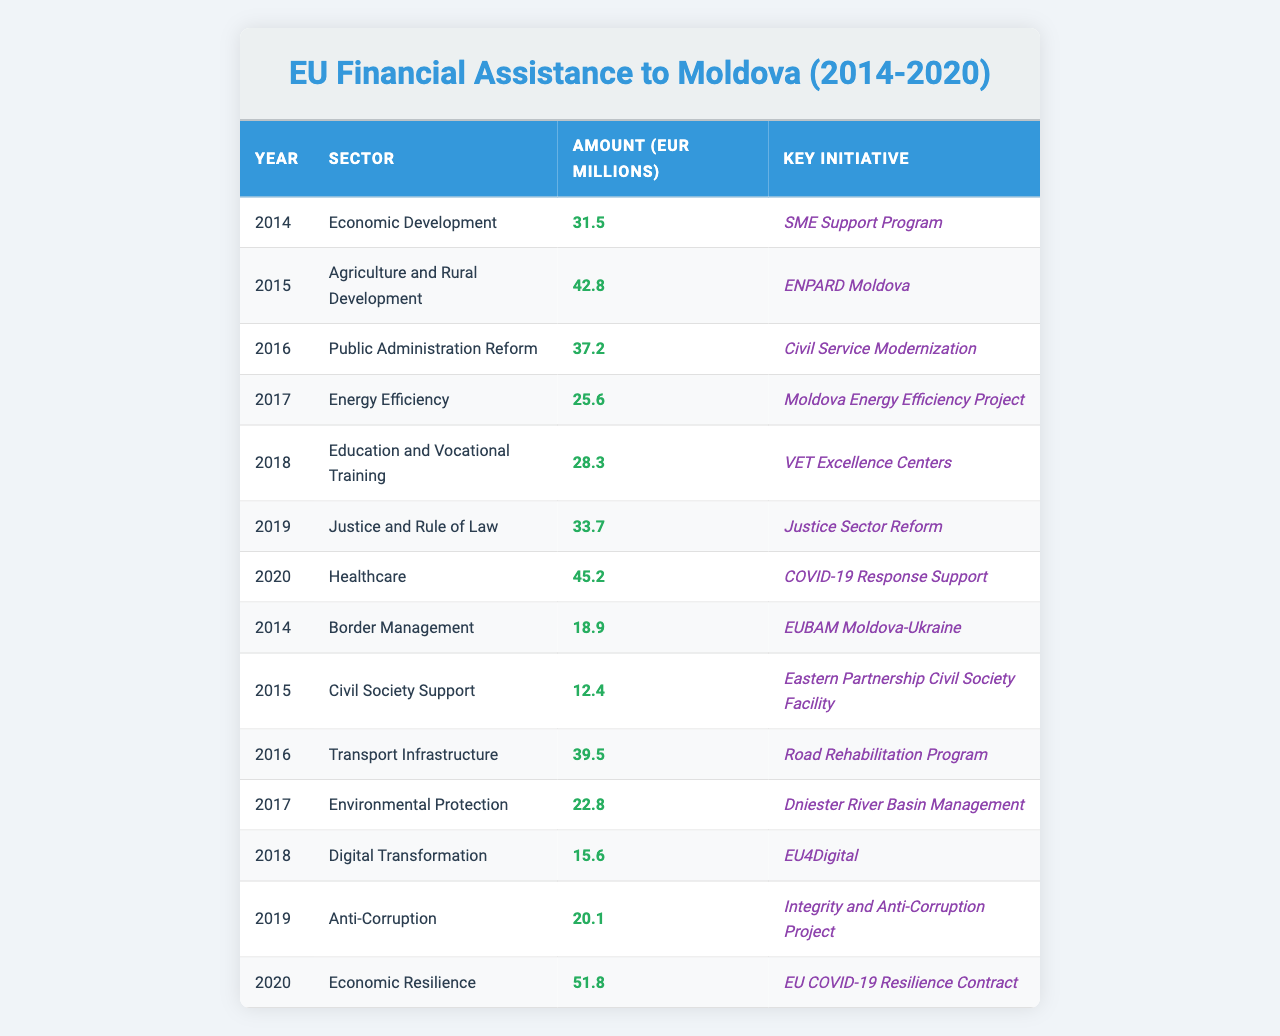What is the total amount of EU financial assistance given to Moldova in 2019? In 2019, the table shows two sectors with financial assistance: Justice and Rule of Law with 33.7 million EUR and Anti-Corruption with 20.1 million EUR. To find the total for 2019, we add these amounts: 33.7 + 20.1 = 53.8 million EUR.
Answer: 53.8 million EUR What was the highest amount of financial assistance in a single year between 2014 and 2020? Looking at the table, the highest single amount is in 2020 under Economic Resilience, which is 51.8 million EUR. All other years have lower amounts.
Answer: 51.8 million EUR In which sector was the least financial assistance provided in 2017? In 2017, the sectors listed are Energy Efficiency with 25.6 million EUR and Environmental Protection with 22.8 million EUR. The least assistance is in Environmental Protection.
Answer: Environmental Protection What is the average amount of financial assistance received in the sector of Economic Development from 2014 to 2020? In the table, Economic Development received 31.5 million EUR in 2014 and 51.8 million EUR in 2020. To find the average, we add these amounts: 31.5 + 51.8 = 83.3 million EUR and divide by 2, which gives 83.3 / 2 = 41.65 million EUR.
Answer: 41.65 million EUR Was there any financial assistance for Digital Transformation in 2019? The table shows that Digital Transformation received assistance of 15.6 million EUR, but it is only listed for 2018. Therefore, there was no financial assistance for Digital Transformation in 2019.
Answer: No What was the total amount of EU financial assistance allocated to Healthcare and Education sectors across all listed years? The Education sector received 28.3 million EUR in 2018, and Healthcare received 45.2 million EUR in 2020. Adding these together gives us a total of 28.3 + 45.2 = 73.5 million EUR.
Answer: 73.5 million EUR Which year had the highest contribution for Agriculture and Rural Development? The table indicates that the only financial assistance under Agriculture and Rural Development was 42.8 million EUR in 2015. This is the highest noted for that sector because only one contribution is shown.
Answer: 2015 How many different sectors received financial assistance from the EU in total between 2014 and 2020? By reviewing the table, we see a total of 14 unique sectors listed, one for each year with varying initiatives.
Answer: 14 sectors Was the amount for Public Administration Reform larger than the amount for Border Management in 2014? Public Administration Reform received 37.2 million EUR in 2016 and Border Management received 18.9 million EUR in 2014. Comparing these amounts shows that 37.2 million EUR is indeed larger than 18.9 million EUR.
Answer: Yes What was the difference in financial assistance between the sectors of Agriculture and Rural Development and Justice and Rule of Law in 2019? The sector of Agriculture and Rural Development received no funds in 2019, while Justice and Rule of Law was allotted 33.7 million EUR. Therefore, the difference is simply 0 - 33.7 = -33.7 million EUR.
Answer: -33.7 million EUR 